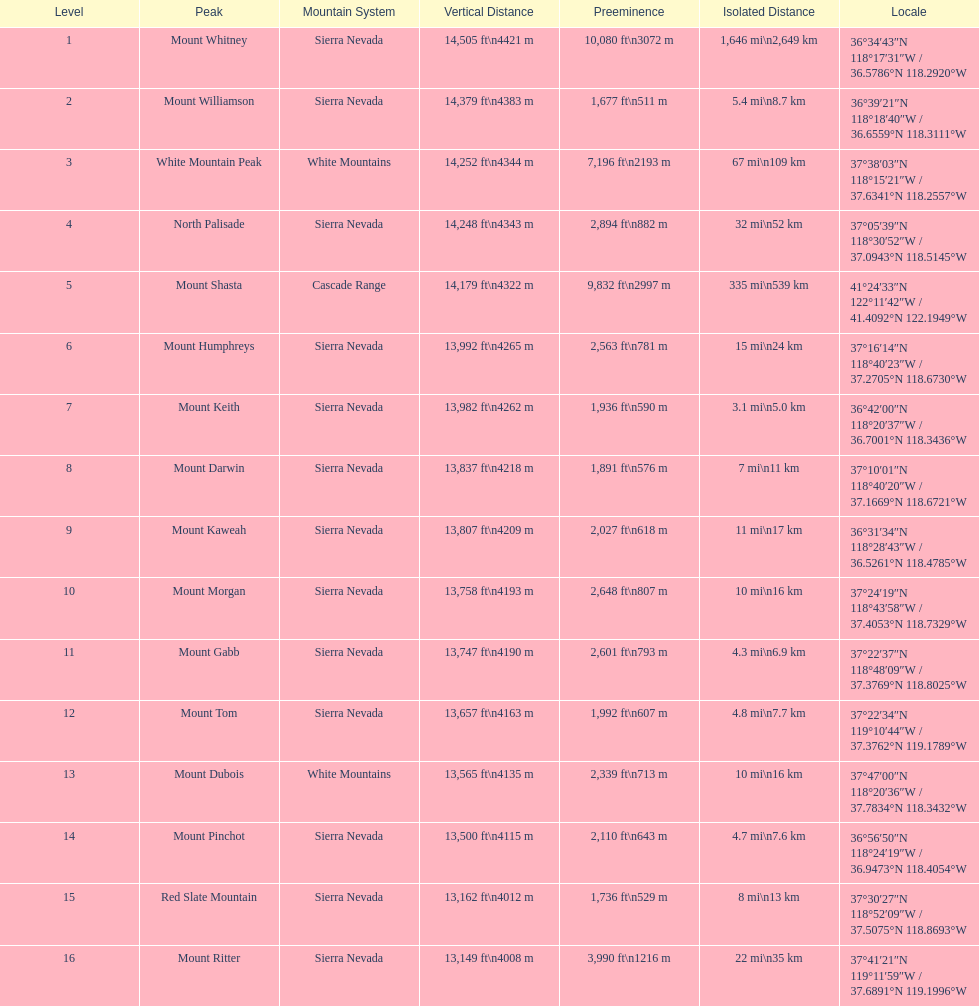Write the full table. {'header': ['Level', 'Peak', 'Mountain System', 'Vertical Distance', 'Preeminence', 'Isolated Distance', 'Locale'], 'rows': [['1', 'Mount Whitney', 'Sierra Nevada', '14,505\xa0ft\\n4421\xa0m', '10,080\xa0ft\\n3072\xa0m', '1,646\xa0mi\\n2,649\xa0km', '36°34′43″N 118°17′31″W\ufeff / \ufeff36.5786°N 118.2920°W'], ['2', 'Mount Williamson', 'Sierra Nevada', '14,379\xa0ft\\n4383\xa0m', '1,677\xa0ft\\n511\xa0m', '5.4\xa0mi\\n8.7\xa0km', '36°39′21″N 118°18′40″W\ufeff / \ufeff36.6559°N 118.3111°W'], ['3', 'White Mountain Peak', 'White Mountains', '14,252\xa0ft\\n4344\xa0m', '7,196\xa0ft\\n2193\xa0m', '67\xa0mi\\n109\xa0km', '37°38′03″N 118°15′21″W\ufeff / \ufeff37.6341°N 118.2557°W'], ['4', 'North Palisade', 'Sierra Nevada', '14,248\xa0ft\\n4343\xa0m', '2,894\xa0ft\\n882\xa0m', '32\xa0mi\\n52\xa0km', '37°05′39″N 118°30′52″W\ufeff / \ufeff37.0943°N 118.5145°W'], ['5', 'Mount Shasta', 'Cascade Range', '14,179\xa0ft\\n4322\xa0m', '9,832\xa0ft\\n2997\xa0m', '335\xa0mi\\n539\xa0km', '41°24′33″N 122°11′42″W\ufeff / \ufeff41.4092°N 122.1949°W'], ['6', 'Mount Humphreys', 'Sierra Nevada', '13,992\xa0ft\\n4265\xa0m', '2,563\xa0ft\\n781\xa0m', '15\xa0mi\\n24\xa0km', '37°16′14″N 118°40′23″W\ufeff / \ufeff37.2705°N 118.6730°W'], ['7', 'Mount Keith', 'Sierra Nevada', '13,982\xa0ft\\n4262\xa0m', '1,936\xa0ft\\n590\xa0m', '3.1\xa0mi\\n5.0\xa0km', '36°42′00″N 118°20′37″W\ufeff / \ufeff36.7001°N 118.3436°W'], ['8', 'Mount Darwin', 'Sierra Nevada', '13,837\xa0ft\\n4218\xa0m', '1,891\xa0ft\\n576\xa0m', '7\xa0mi\\n11\xa0km', '37°10′01″N 118°40′20″W\ufeff / \ufeff37.1669°N 118.6721°W'], ['9', 'Mount Kaweah', 'Sierra Nevada', '13,807\xa0ft\\n4209\xa0m', '2,027\xa0ft\\n618\xa0m', '11\xa0mi\\n17\xa0km', '36°31′34″N 118°28′43″W\ufeff / \ufeff36.5261°N 118.4785°W'], ['10', 'Mount Morgan', 'Sierra Nevada', '13,758\xa0ft\\n4193\xa0m', '2,648\xa0ft\\n807\xa0m', '10\xa0mi\\n16\xa0km', '37°24′19″N 118°43′58″W\ufeff / \ufeff37.4053°N 118.7329°W'], ['11', 'Mount Gabb', 'Sierra Nevada', '13,747\xa0ft\\n4190\xa0m', '2,601\xa0ft\\n793\xa0m', '4.3\xa0mi\\n6.9\xa0km', '37°22′37″N 118°48′09″W\ufeff / \ufeff37.3769°N 118.8025°W'], ['12', 'Mount Tom', 'Sierra Nevada', '13,657\xa0ft\\n4163\xa0m', '1,992\xa0ft\\n607\xa0m', '4.8\xa0mi\\n7.7\xa0km', '37°22′34″N 119°10′44″W\ufeff / \ufeff37.3762°N 119.1789°W'], ['13', 'Mount Dubois', 'White Mountains', '13,565\xa0ft\\n4135\xa0m', '2,339\xa0ft\\n713\xa0m', '10\xa0mi\\n16\xa0km', '37°47′00″N 118°20′36″W\ufeff / \ufeff37.7834°N 118.3432°W'], ['14', 'Mount Pinchot', 'Sierra Nevada', '13,500\xa0ft\\n4115\xa0m', '2,110\xa0ft\\n643\xa0m', '4.7\xa0mi\\n7.6\xa0km', '36°56′50″N 118°24′19″W\ufeff / \ufeff36.9473°N 118.4054°W'], ['15', 'Red Slate Mountain', 'Sierra Nevada', '13,162\xa0ft\\n4012\xa0m', '1,736\xa0ft\\n529\xa0m', '8\xa0mi\\n13\xa0km', '37°30′27″N 118°52′09″W\ufeff / \ufeff37.5075°N 118.8693°W'], ['16', 'Mount Ritter', 'Sierra Nevada', '13,149\xa0ft\\n4008\xa0m', '3,990\xa0ft\\n1216\xa0m', '22\xa0mi\\n35\xa0km', '37°41′21″N 119°11′59″W\ufeff / \ufeff37.6891°N 119.1996°W']]} Which mountain peak is no higher than 13,149 ft? Mount Ritter. 